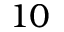Convert formula to latex. <formula><loc_0><loc_0><loc_500><loc_500>1 0</formula> 